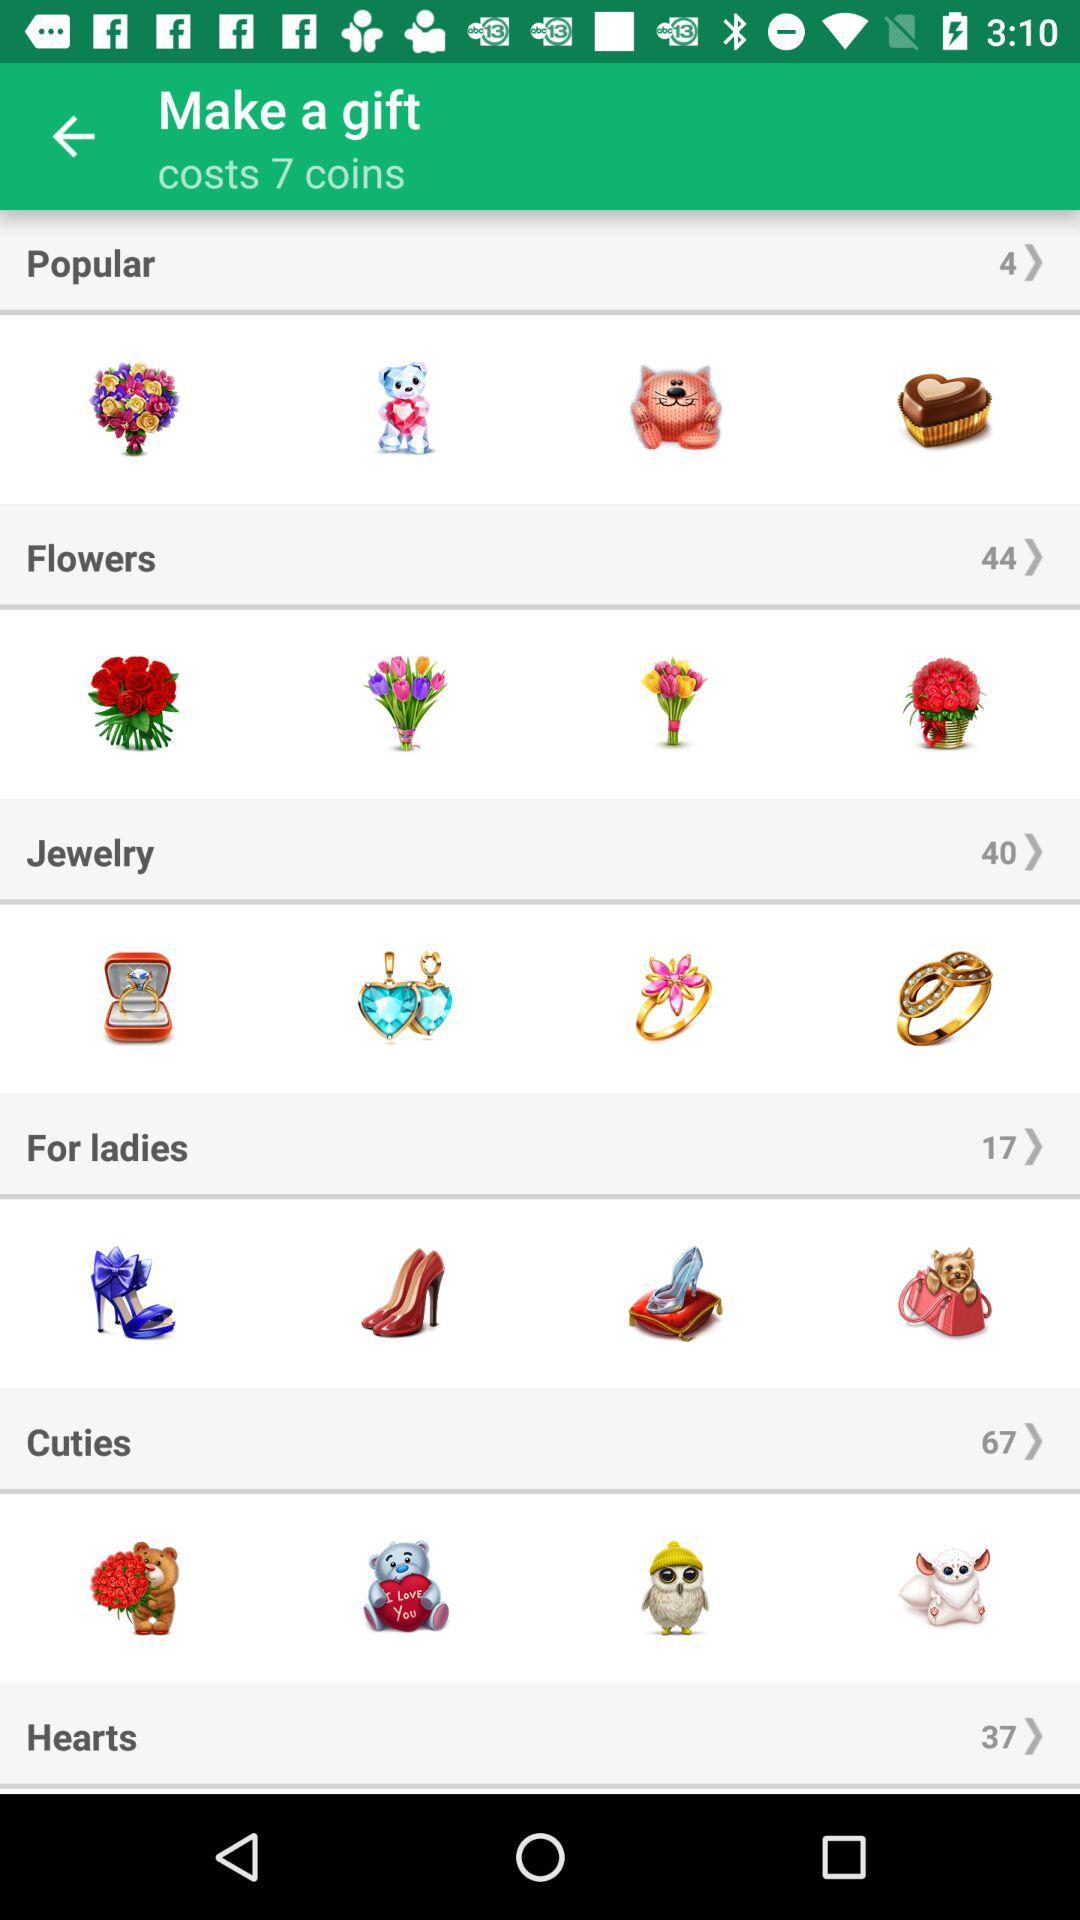Which section has 44 counts? The section is "Flowers". 